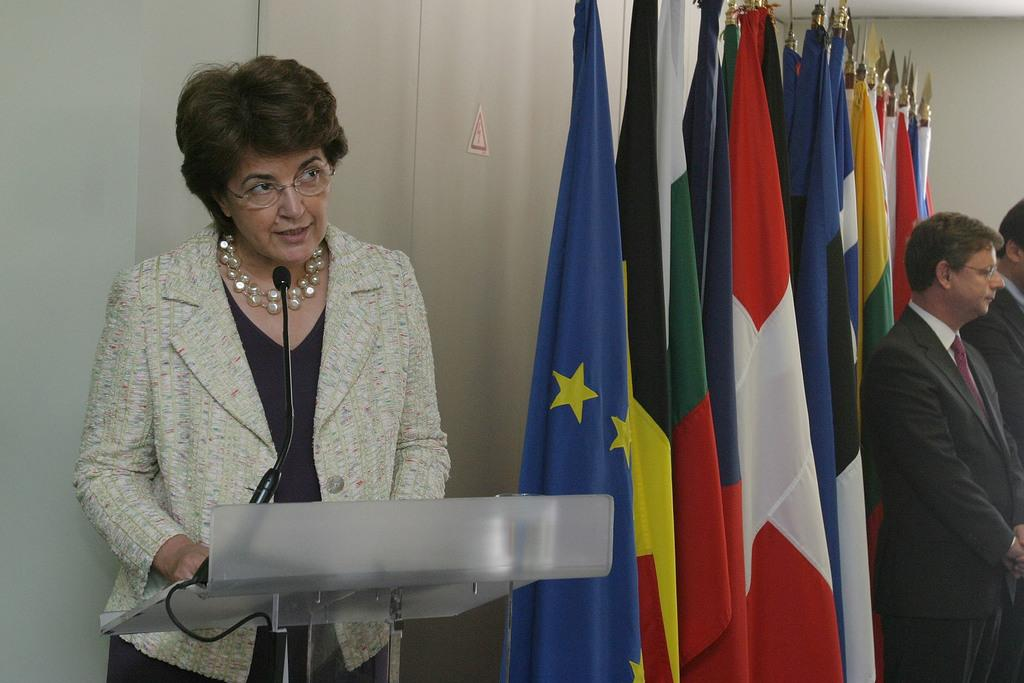What is the main object in the image? There is a podium with a mic in the image. Who is standing behind the podium? A lady is standing behind the podium. What can be seen beside the lady? There are flags beside the lady. What else is present in the image? There are two men in the right corner of the image. What type of frame is surrounding the lady in the image? There is no frame surrounding the lady in the image. What point is the lady trying to make while standing behind the podium? The image does not provide any information about the lady's message or point, as it only shows her standing behind the podium with flags beside her. 